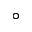Convert formula to latex. <formula><loc_0><loc_0><loc_500><loc_500>^ { \circ }</formula> 